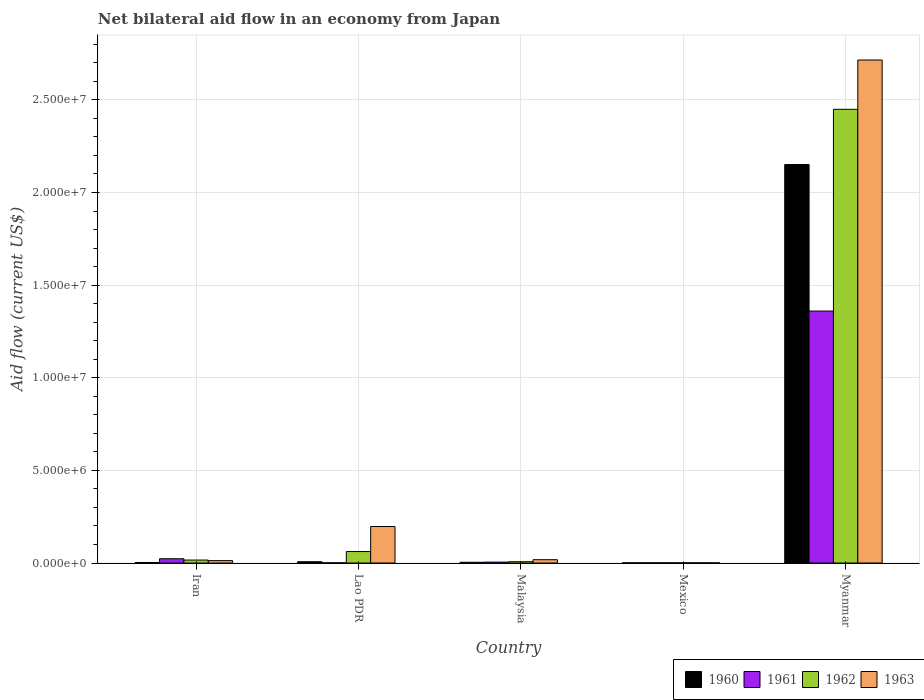How many groups of bars are there?
Offer a terse response. 5. How many bars are there on the 4th tick from the left?
Your answer should be very brief. 4. How many bars are there on the 3rd tick from the right?
Ensure brevity in your answer.  4. What is the label of the 3rd group of bars from the left?
Keep it short and to the point. Malaysia. Across all countries, what is the maximum net bilateral aid flow in 1961?
Offer a terse response. 1.36e+07. Across all countries, what is the minimum net bilateral aid flow in 1963?
Offer a very short reply. 10000. In which country was the net bilateral aid flow in 1963 maximum?
Give a very brief answer. Myanmar. In which country was the net bilateral aid flow in 1961 minimum?
Keep it short and to the point. Lao PDR. What is the total net bilateral aid flow in 1961 in the graph?
Ensure brevity in your answer.  1.39e+07. What is the difference between the net bilateral aid flow in 1960 in Malaysia and that in Myanmar?
Give a very brief answer. -2.15e+07. What is the average net bilateral aid flow in 1960 per country?
Offer a very short reply. 4.33e+06. What is the ratio of the net bilateral aid flow in 1963 in Lao PDR to that in Malaysia?
Your answer should be very brief. 10.94. Is the net bilateral aid flow in 1961 in Lao PDR less than that in Mexico?
Keep it short and to the point. No. Is the difference between the net bilateral aid flow in 1961 in Iran and Malaysia greater than the difference between the net bilateral aid flow in 1960 in Iran and Malaysia?
Provide a succinct answer. Yes. What is the difference between the highest and the second highest net bilateral aid flow in 1962?
Make the answer very short. 2.43e+07. What is the difference between the highest and the lowest net bilateral aid flow in 1962?
Keep it short and to the point. 2.45e+07. In how many countries, is the net bilateral aid flow in 1962 greater than the average net bilateral aid flow in 1962 taken over all countries?
Provide a succinct answer. 1. Is the sum of the net bilateral aid flow in 1960 in Iran and Lao PDR greater than the maximum net bilateral aid flow in 1962 across all countries?
Provide a succinct answer. No. Is it the case that in every country, the sum of the net bilateral aid flow in 1962 and net bilateral aid flow in 1961 is greater than the sum of net bilateral aid flow in 1963 and net bilateral aid flow in 1960?
Make the answer very short. No. Is it the case that in every country, the sum of the net bilateral aid flow in 1962 and net bilateral aid flow in 1961 is greater than the net bilateral aid flow in 1960?
Your response must be concise. Yes. Are all the bars in the graph horizontal?
Keep it short and to the point. No. How many countries are there in the graph?
Provide a succinct answer. 5. Are the values on the major ticks of Y-axis written in scientific E-notation?
Your response must be concise. Yes. Does the graph contain grids?
Make the answer very short. Yes. Where does the legend appear in the graph?
Offer a very short reply. Bottom right. How are the legend labels stacked?
Provide a short and direct response. Horizontal. What is the title of the graph?
Give a very brief answer. Net bilateral aid flow in an economy from Japan. Does "2008" appear as one of the legend labels in the graph?
Ensure brevity in your answer.  No. What is the label or title of the X-axis?
Provide a short and direct response. Country. What is the Aid flow (current US$) of 1960 in Iran?
Provide a succinct answer. 3.00e+04. What is the Aid flow (current US$) of 1962 in Iran?
Offer a terse response. 1.60e+05. What is the Aid flow (current US$) in 1963 in Iran?
Keep it short and to the point. 1.30e+05. What is the Aid flow (current US$) in 1960 in Lao PDR?
Make the answer very short. 7.00e+04. What is the Aid flow (current US$) in 1961 in Lao PDR?
Offer a terse response. 10000. What is the Aid flow (current US$) in 1962 in Lao PDR?
Your answer should be compact. 6.20e+05. What is the Aid flow (current US$) in 1963 in Lao PDR?
Provide a short and direct response. 1.97e+06. What is the Aid flow (current US$) of 1961 in Malaysia?
Give a very brief answer. 5.00e+04. What is the Aid flow (current US$) in 1960 in Mexico?
Provide a short and direct response. 10000. What is the Aid flow (current US$) in 1961 in Mexico?
Your response must be concise. 10000. What is the Aid flow (current US$) of 1962 in Mexico?
Make the answer very short. 10000. What is the Aid flow (current US$) of 1963 in Mexico?
Keep it short and to the point. 10000. What is the Aid flow (current US$) in 1960 in Myanmar?
Ensure brevity in your answer.  2.15e+07. What is the Aid flow (current US$) in 1961 in Myanmar?
Keep it short and to the point. 1.36e+07. What is the Aid flow (current US$) in 1962 in Myanmar?
Offer a terse response. 2.45e+07. What is the Aid flow (current US$) in 1963 in Myanmar?
Give a very brief answer. 2.72e+07. Across all countries, what is the maximum Aid flow (current US$) in 1960?
Provide a short and direct response. 2.15e+07. Across all countries, what is the maximum Aid flow (current US$) of 1961?
Give a very brief answer. 1.36e+07. Across all countries, what is the maximum Aid flow (current US$) of 1962?
Offer a very short reply. 2.45e+07. Across all countries, what is the maximum Aid flow (current US$) of 1963?
Your answer should be compact. 2.72e+07. What is the total Aid flow (current US$) in 1960 in the graph?
Give a very brief answer. 2.17e+07. What is the total Aid flow (current US$) of 1961 in the graph?
Your answer should be compact. 1.39e+07. What is the total Aid flow (current US$) of 1962 in the graph?
Provide a succinct answer. 2.54e+07. What is the total Aid flow (current US$) of 1963 in the graph?
Your answer should be compact. 2.94e+07. What is the difference between the Aid flow (current US$) of 1961 in Iran and that in Lao PDR?
Offer a terse response. 2.20e+05. What is the difference between the Aid flow (current US$) in 1962 in Iran and that in Lao PDR?
Provide a short and direct response. -4.60e+05. What is the difference between the Aid flow (current US$) of 1963 in Iran and that in Lao PDR?
Keep it short and to the point. -1.84e+06. What is the difference between the Aid flow (current US$) in 1960 in Iran and that in Malaysia?
Give a very brief answer. -10000. What is the difference between the Aid flow (current US$) of 1963 in Iran and that in Malaysia?
Give a very brief answer. -5.00e+04. What is the difference between the Aid flow (current US$) of 1960 in Iran and that in Mexico?
Give a very brief answer. 2.00e+04. What is the difference between the Aid flow (current US$) of 1961 in Iran and that in Mexico?
Give a very brief answer. 2.20e+05. What is the difference between the Aid flow (current US$) of 1962 in Iran and that in Mexico?
Offer a terse response. 1.50e+05. What is the difference between the Aid flow (current US$) of 1963 in Iran and that in Mexico?
Your answer should be compact. 1.20e+05. What is the difference between the Aid flow (current US$) in 1960 in Iran and that in Myanmar?
Give a very brief answer. -2.15e+07. What is the difference between the Aid flow (current US$) of 1961 in Iran and that in Myanmar?
Offer a very short reply. -1.34e+07. What is the difference between the Aid flow (current US$) in 1962 in Iran and that in Myanmar?
Provide a short and direct response. -2.43e+07. What is the difference between the Aid flow (current US$) in 1963 in Iran and that in Myanmar?
Your answer should be very brief. -2.70e+07. What is the difference between the Aid flow (current US$) in 1960 in Lao PDR and that in Malaysia?
Your response must be concise. 3.00e+04. What is the difference between the Aid flow (current US$) in 1963 in Lao PDR and that in Malaysia?
Provide a succinct answer. 1.79e+06. What is the difference between the Aid flow (current US$) of 1960 in Lao PDR and that in Mexico?
Your answer should be compact. 6.00e+04. What is the difference between the Aid flow (current US$) of 1961 in Lao PDR and that in Mexico?
Your response must be concise. 0. What is the difference between the Aid flow (current US$) of 1962 in Lao PDR and that in Mexico?
Ensure brevity in your answer.  6.10e+05. What is the difference between the Aid flow (current US$) of 1963 in Lao PDR and that in Mexico?
Keep it short and to the point. 1.96e+06. What is the difference between the Aid flow (current US$) of 1960 in Lao PDR and that in Myanmar?
Your answer should be very brief. -2.14e+07. What is the difference between the Aid flow (current US$) in 1961 in Lao PDR and that in Myanmar?
Offer a very short reply. -1.36e+07. What is the difference between the Aid flow (current US$) of 1962 in Lao PDR and that in Myanmar?
Your answer should be compact. -2.39e+07. What is the difference between the Aid flow (current US$) in 1963 in Lao PDR and that in Myanmar?
Your answer should be very brief. -2.52e+07. What is the difference between the Aid flow (current US$) in 1963 in Malaysia and that in Mexico?
Give a very brief answer. 1.70e+05. What is the difference between the Aid flow (current US$) of 1960 in Malaysia and that in Myanmar?
Ensure brevity in your answer.  -2.15e+07. What is the difference between the Aid flow (current US$) of 1961 in Malaysia and that in Myanmar?
Offer a terse response. -1.36e+07. What is the difference between the Aid flow (current US$) of 1962 in Malaysia and that in Myanmar?
Ensure brevity in your answer.  -2.44e+07. What is the difference between the Aid flow (current US$) of 1963 in Malaysia and that in Myanmar?
Make the answer very short. -2.70e+07. What is the difference between the Aid flow (current US$) of 1960 in Mexico and that in Myanmar?
Offer a very short reply. -2.15e+07. What is the difference between the Aid flow (current US$) in 1961 in Mexico and that in Myanmar?
Provide a succinct answer. -1.36e+07. What is the difference between the Aid flow (current US$) in 1962 in Mexico and that in Myanmar?
Give a very brief answer. -2.45e+07. What is the difference between the Aid flow (current US$) in 1963 in Mexico and that in Myanmar?
Your answer should be compact. -2.71e+07. What is the difference between the Aid flow (current US$) in 1960 in Iran and the Aid flow (current US$) in 1962 in Lao PDR?
Offer a very short reply. -5.90e+05. What is the difference between the Aid flow (current US$) in 1960 in Iran and the Aid flow (current US$) in 1963 in Lao PDR?
Your answer should be compact. -1.94e+06. What is the difference between the Aid flow (current US$) in 1961 in Iran and the Aid flow (current US$) in 1962 in Lao PDR?
Make the answer very short. -3.90e+05. What is the difference between the Aid flow (current US$) of 1961 in Iran and the Aid flow (current US$) of 1963 in Lao PDR?
Keep it short and to the point. -1.74e+06. What is the difference between the Aid flow (current US$) in 1962 in Iran and the Aid flow (current US$) in 1963 in Lao PDR?
Offer a terse response. -1.81e+06. What is the difference between the Aid flow (current US$) in 1960 in Iran and the Aid flow (current US$) in 1961 in Malaysia?
Keep it short and to the point. -2.00e+04. What is the difference between the Aid flow (current US$) in 1962 in Iran and the Aid flow (current US$) in 1963 in Malaysia?
Your answer should be compact. -2.00e+04. What is the difference between the Aid flow (current US$) in 1960 in Iran and the Aid flow (current US$) in 1962 in Mexico?
Your response must be concise. 2.00e+04. What is the difference between the Aid flow (current US$) of 1961 in Iran and the Aid flow (current US$) of 1963 in Mexico?
Your answer should be very brief. 2.20e+05. What is the difference between the Aid flow (current US$) of 1962 in Iran and the Aid flow (current US$) of 1963 in Mexico?
Offer a terse response. 1.50e+05. What is the difference between the Aid flow (current US$) in 1960 in Iran and the Aid flow (current US$) in 1961 in Myanmar?
Your response must be concise. -1.36e+07. What is the difference between the Aid flow (current US$) of 1960 in Iran and the Aid flow (current US$) of 1962 in Myanmar?
Offer a very short reply. -2.45e+07. What is the difference between the Aid flow (current US$) in 1960 in Iran and the Aid flow (current US$) in 1963 in Myanmar?
Provide a short and direct response. -2.71e+07. What is the difference between the Aid flow (current US$) of 1961 in Iran and the Aid flow (current US$) of 1962 in Myanmar?
Ensure brevity in your answer.  -2.43e+07. What is the difference between the Aid flow (current US$) of 1961 in Iran and the Aid flow (current US$) of 1963 in Myanmar?
Provide a succinct answer. -2.69e+07. What is the difference between the Aid flow (current US$) in 1962 in Iran and the Aid flow (current US$) in 1963 in Myanmar?
Offer a very short reply. -2.70e+07. What is the difference between the Aid flow (current US$) of 1960 in Lao PDR and the Aid flow (current US$) of 1963 in Malaysia?
Keep it short and to the point. -1.10e+05. What is the difference between the Aid flow (current US$) of 1961 in Lao PDR and the Aid flow (current US$) of 1962 in Malaysia?
Make the answer very short. -6.00e+04. What is the difference between the Aid flow (current US$) in 1961 in Lao PDR and the Aid flow (current US$) in 1963 in Malaysia?
Provide a short and direct response. -1.70e+05. What is the difference between the Aid flow (current US$) in 1962 in Lao PDR and the Aid flow (current US$) in 1963 in Malaysia?
Your answer should be very brief. 4.40e+05. What is the difference between the Aid flow (current US$) in 1960 in Lao PDR and the Aid flow (current US$) in 1961 in Mexico?
Make the answer very short. 6.00e+04. What is the difference between the Aid flow (current US$) in 1960 in Lao PDR and the Aid flow (current US$) in 1962 in Mexico?
Your answer should be very brief. 6.00e+04. What is the difference between the Aid flow (current US$) in 1960 in Lao PDR and the Aid flow (current US$) in 1963 in Mexico?
Your response must be concise. 6.00e+04. What is the difference between the Aid flow (current US$) of 1961 in Lao PDR and the Aid flow (current US$) of 1962 in Mexico?
Your answer should be very brief. 0. What is the difference between the Aid flow (current US$) in 1962 in Lao PDR and the Aid flow (current US$) in 1963 in Mexico?
Provide a succinct answer. 6.10e+05. What is the difference between the Aid flow (current US$) of 1960 in Lao PDR and the Aid flow (current US$) of 1961 in Myanmar?
Ensure brevity in your answer.  -1.35e+07. What is the difference between the Aid flow (current US$) in 1960 in Lao PDR and the Aid flow (current US$) in 1962 in Myanmar?
Your answer should be compact. -2.44e+07. What is the difference between the Aid flow (current US$) of 1960 in Lao PDR and the Aid flow (current US$) of 1963 in Myanmar?
Your answer should be compact. -2.71e+07. What is the difference between the Aid flow (current US$) in 1961 in Lao PDR and the Aid flow (current US$) in 1962 in Myanmar?
Provide a short and direct response. -2.45e+07. What is the difference between the Aid flow (current US$) of 1961 in Lao PDR and the Aid flow (current US$) of 1963 in Myanmar?
Ensure brevity in your answer.  -2.71e+07. What is the difference between the Aid flow (current US$) of 1962 in Lao PDR and the Aid flow (current US$) of 1963 in Myanmar?
Ensure brevity in your answer.  -2.65e+07. What is the difference between the Aid flow (current US$) of 1960 in Malaysia and the Aid flow (current US$) of 1961 in Mexico?
Ensure brevity in your answer.  3.00e+04. What is the difference between the Aid flow (current US$) of 1960 in Malaysia and the Aid flow (current US$) of 1962 in Mexico?
Offer a terse response. 3.00e+04. What is the difference between the Aid flow (current US$) in 1961 in Malaysia and the Aid flow (current US$) in 1962 in Mexico?
Ensure brevity in your answer.  4.00e+04. What is the difference between the Aid flow (current US$) of 1962 in Malaysia and the Aid flow (current US$) of 1963 in Mexico?
Keep it short and to the point. 6.00e+04. What is the difference between the Aid flow (current US$) in 1960 in Malaysia and the Aid flow (current US$) in 1961 in Myanmar?
Keep it short and to the point. -1.36e+07. What is the difference between the Aid flow (current US$) in 1960 in Malaysia and the Aid flow (current US$) in 1962 in Myanmar?
Ensure brevity in your answer.  -2.44e+07. What is the difference between the Aid flow (current US$) in 1960 in Malaysia and the Aid flow (current US$) in 1963 in Myanmar?
Provide a succinct answer. -2.71e+07. What is the difference between the Aid flow (current US$) of 1961 in Malaysia and the Aid flow (current US$) of 1962 in Myanmar?
Offer a terse response. -2.44e+07. What is the difference between the Aid flow (current US$) in 1961 in Malaysia and the Aid flow (current US$) in 1963 in Myanmar?
Your response must be concise. -2.71e+07. What is the difference between the Aid flow (current US$) in 1962 in Malaysia and the Aid flow (current US$) in 1963 in Myanmar?
Your answer should be compact. -2.71e+07. What is the difference between the Aid flow (current US$) of 1960 in Mexico and the Aid flow (current US$) of 1961 in Myanmar?
Give a very brief answer. -1.36e+07. What is the difference between the Aid flow (current US$) of 1960 in Mexico and the Aid flow (current US$) of 1962 in Myanmar?
Keep it short and to the point. -2.45e+07. What is the difference between the Aid flow (current US$) in 1960 in Mexico and the Aid flow (current US$) in 1963 in Myanmar?
Your answer should be very brief. -2.71e+07. What is the difference between the Aid flow (current US$) in 1961 in Mexico and the Aid flow (current US$) in 1962 in Myanmar?
Your answer should be very brief. -2.45e+07. What is the difference between the Aid flow (current US$) of 1961 in Mexico and the Aid flow (current US$) of 1963 in Myanmar?
Offer a very short reply. -2.71e+07. What is the difference between the Aid flow (current US$) in 1962 in Mexico and the Aid flow (current US$) in 1963 in Myanmar?
Provide a succinct answer. -2.71e+07. What is the average Aid flow (current US$) of 1960 per country?
Your answer should be compact. 4.33e+06. What is the average Aid flow (current US$) of 1961 per country?
Ensure brevity in your answer.  2.78e+06. What is the average Aid flow (current US$) of 1962 per country?
Offer a terse response. 5.07e+06. What is the average Aid flow (current US$) in 1963 per country?
Your answer should be compact. 5.89e+06. What is the difference between the Aid flow (current US$) in 1960 and Aid flow (current US$) in 1961 in Lao PDR?
Ensure brevity in your answer.  6.00e+04. What is the difference between the Aid flow (current US$) of 1960 and Aid flow (current US$) of 1962 in Lao PDR?
Make the answer very short. -5.50e+05. What is the difference between the Aid flow (current US$) of 1960 and Aid flow (current US$) of 1963 in Lao PDR?
Offer a terse response. -1.90e+06. What is the difference between the Aid flow (current US$) of 1961 and Aid flow (current US$) of 1962 in Lao PDR?
Make the answer very short. -6.10e+05. What is the difference between the Aid flow (current US$) of 1961 and Aid flow (current US$) of 1963 in Lao PDR?
Offer a very short reply. -1.96e+06. What is the difference between the Aid flow (current US$) in 1962 and Aid flow (current US$) in 1963 in Lao PDR?
Your answer should be very brief. -1.35e+06. What is the difference between the Aid flow (current US$) in 1960 and Aid flow (current US$) in 1962 in Malaysia?
Offer a very short reply. -3.00e+04. What is the difference between the Aid flow (current US$) of 1961 and Aid flow (current US$) of 1963 in Malaysia?
Your response must be concise. -1.30e+05. What is the difference between the Aid flow (current US$) of 1962 and Aid flow (current US$) of 1963 in Malaysia?
Your answer should be very brief. -1.10e+05. What is the difference between the Aid flow (current US$) of 1960 and Aid flow (current US$) of 1961 in Mexico?
Give a very brief answer. 0. What is the difference between the Aid flow (current US$) of 1960 and Aid flow (current US$) of 1963 in Mexico?
Your answer should be very brief. 0. What is the difference between the Aid flow (current US$) of 1960 and Aid flow (current US$) of 1961 in Myanmar?
Your answer should be compact. 7.91e+06. What is the difference between the Aid flow (current US$) in 1960 and Aid flow (current US$) in 1962 in Myanmar?
Your answer should be very brief. -2.98e+06. What is the difference between the Aid flow (current US$) of 1960 and Aid flow (current US$) of 1963 in Myanmar?
Offer a terse response. -5.64e+06. What is the difference between the Aid flow (current US$) in 1961 and Aid flow (current US$) in 1962 in Myanmar?
Give a very brief answer. -1.09e+07. What is the difference between the Aid flow (current US$) of 1961 and Aid flow (current US$) of 1963 in Myanmar?
Offer a very short reply. -1.36e+07. What is the difference between the Aid flow (current US$) in 1962 and Aid flow (current US$) in 1963 in Myanmar?
Keep it short and to the point. -2.66e+06. What is the ratio of the Aid flow (current US$) in 1960 in Iran to that in Lao PDR?
Ensure brevity in your answer.  0.43. What is the ratio of the Aid flow (current US$) in 1962 in Iran to that in Lao PDR?
Ensure brevity in your answer.  0.26. What is the ratio of the Aid flow (current US$) of 1963 in Iran to that in Lao PDR?
Provide a short and direct response. 0.07. What is the ratio of the Aid flow (current US$) of 1960 in Iran to that in Malaysia?
Make the answer very short. 0.75. What is the ratio of the Aid flow (current US$) of 1962 in Iran to that in Malaysia?
Offer a terse response. 2.29. What is the ratio of the Aid flow (current US$) in 1963 in Iran to that in Malaysia?
Offer a terse response. 0.72. What is the ratio of the Aid flow (current US$) in 1962 in Iran to that in Mexico?
Give a very brief answer. 16. What is the ratio of the Aid flow (current US$) in 1960 in Iran to that in Myanmar?
Provide a short and direct response. 0. What is the ratio of the Aid flow (current US$) of 1961 in Iran to that in Myanmar?
Your answer should be compact. 0.02. What is the ratio of the Aid flow (current US$) in 1962 in Iran to that in Myanmar?
Your answer should be very brief. 0.01. What is the ratio of the Aid flow (current US$) in 1963 in Iran to that in Myanmar?
Ensure brevity in your answer.  0. What is the ratio of the Aid flow (current US$) in 1960 in Lao PDR to that in Malaysia?
Your answer should be compact. 1.75. What is the ratio of the Aid flow (current US$) of 1961 in Lao PDR to that in Malaysia?
Provide a short and direct response. 0.2. What is the ratio of the Aid flow (current US$) of 1962 in Lao PDR to that in Malaysia?
Your answer should be compact. 8.86. What is the ratio of the Aid flow (current US$) of 1963 in Lao PDR to that in Malaysia?
Your answer should be very brief. 10.94. What is the ratio of the Aid flow (current US$) in 1961 in Lao PDR to that in Mexico?
Make the answer very short. 1. What is the ratio of the Aid flow (current US$) of 1963 in Lao PDR to that in Mexico?
Give a very brief answer. 197. What is the ratio of the Aid flow (current US$) in 1960 in Lao PDR to that in Myanmar?
Offer a terse response. 0. What is the ratio of the Aid flow (current US$) in 1961 in Lao PDR to that in Myanmar?
Give a very brief answer. 0. What is the ratio of the Aid flow (current US$) of 1962 in Lao PDR to that in Myanmar?
Your answer should be very brief. 0.03. What is the ratio of the Aid flow (current US$) in 1963 in Lao PDR to that in Myanmar?
Provide a succinct answer. 0.07. What is the ratio of the Aid flow (current US$) in 1961 in Malaysia to that in Mexico?
Make the answer very short. 5. What is the ratio of the Aid flow (current US$) in 1962 in Malaysia to that in Mexico?
Provide a succinct answer. 7. What is the ratio of the Aid flow (current US$) in 1960 in Malaysia to that in Myanmar?
Your answer should be compact. 0. What is the ratio of the Aid flow (current US$) in 1961 in Malaysia to that in Myanmar?
Keep it short and to the point. 0. What is the ratio of the Aid flow (current US$) in 1962 in Malaysia to that in Myanmar?
Your answer should be very brief. 0. What is the ratio of the Aid flow (current US$) in 1963 in Malaysia to that in Myanmar?
Provide a succinct answer. 0.01. What is the ratio of the Aid flow (current US$) of 1961 in Mexico to that in Myanmar?
Offer a terse response. 0. What is the difference between the highest and the second highest Aid flow (current US$) of 1960?
Ensure brevity in your answer.  2.14e+07. What is the difference between the highest and the second highest Aid flow (current US$) in 1961?
Your answer should be very brief. 1.34e+07. What is the difference between the highest and the second highest Aid flow (current US$) of 1962?
Ensure brevity in your answer.  2.39e+07. What is the difference between the highest and the second highest Aid flow (current US$) of 1963?
Your answer should be very brief. 2.52e+07. What is the difference between the highest and the lowest Aid flow (current US$) of 1960?
Give a very brief answer. 2.15e+07. What is the difference between the highest and the lowest Aid flow (current US$) in 1961?
Provide a short and direct response. 1.36e+07. What is the difference between the highest and the lowest Aid flow (current US$) in 1962?
Your response must be concise. 2.45e+07. What is the difference between the highest and the lowest Aid flow (current US$) in 1963?
Provide a succinct answer. 2.71e+07. 